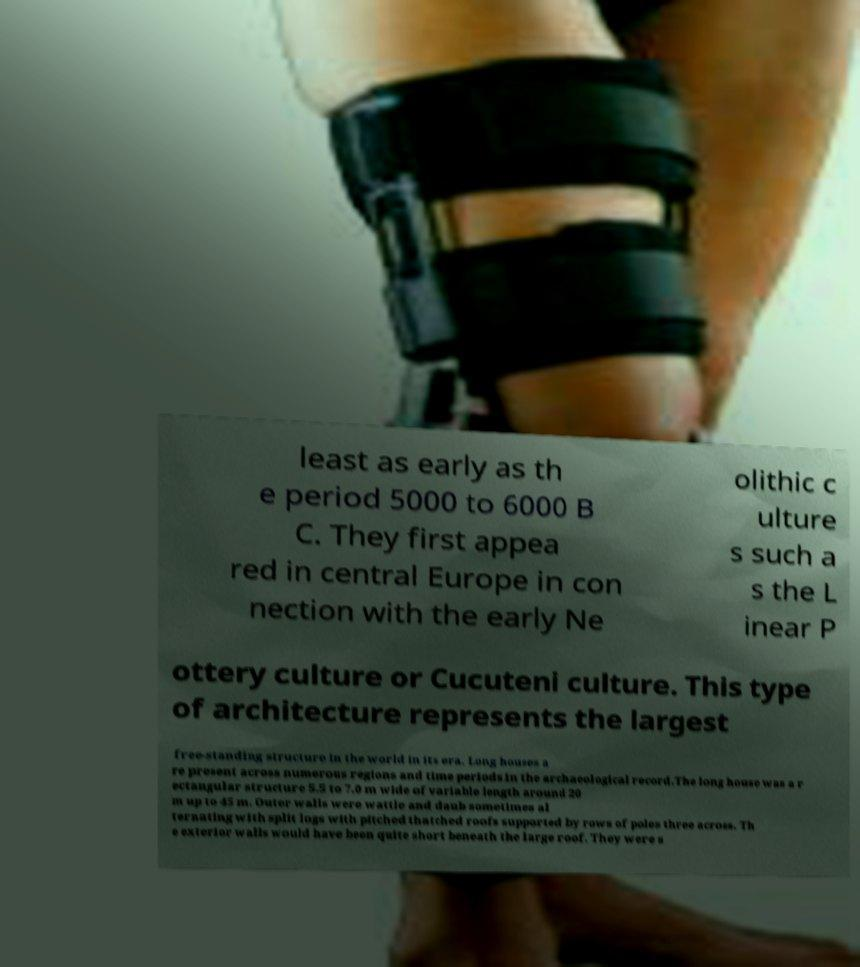For documentation purposes, I need the text within this image transcribed. Could you provide that? least as early as th e period 5000 to 6000 B C. They first appea red in central Europe in con nection with the early Ne olithic c ulture s such a s the L inear P ottery culture or Cucuteni culture. This type of architecture represents the largest free-standing structure in the world in its era. Long houses a re present across numerous regions and time periods in the archaeological record.The long house was a r ectangular structure 5.5 to 7.0 m wide of variable length around 20 m up to 45 m. Outer walls were wattle and daub sometimes al ternating with split logs with pitched thatched roofs supported by rows of poles three across. Th e exterior walls would have been quite short beneath the large roof. They were s 